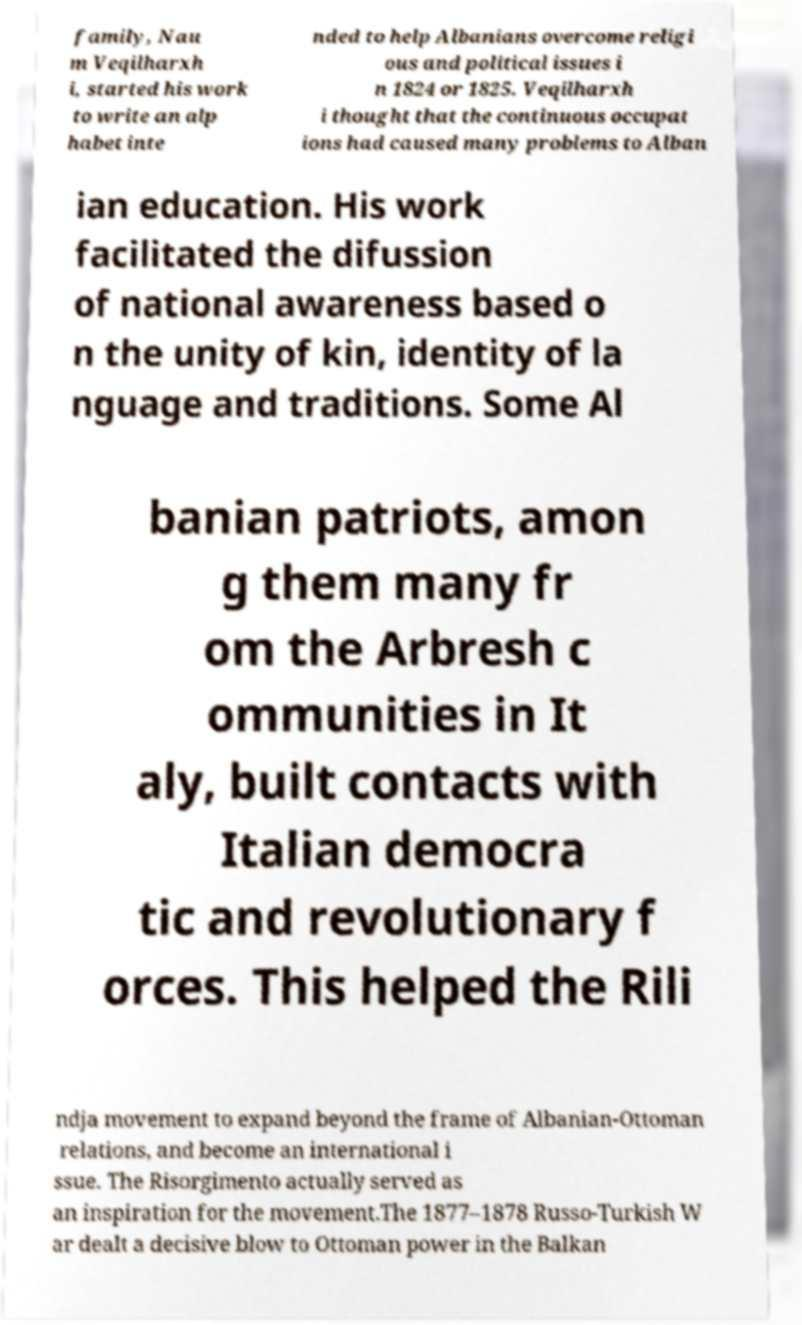Can you accurately transcribe the text from the provided image for me? family, Nau m Veqilharxh i, started his work to write an alp habet inte nded to help Albanians overcome religi ous and political issues i n 1824 or 1825. Veqilharxh i thought that the continuous occupat ions had caused many problems to Alban ian education. His work facilitated the difussion of national awareness based o n the unity of kin, identity of la nguage and traditions. Some Al banian patriots, amon g them many fr om the Arbresh c ommunities in It aly, built contacts with Italian democra tic and revolutionary f orces. This helped the Rili ndja movement to expand beyond the frame of Albanian-Ottoman relations, and become an international i ssue. The Risorgimento actually served as an inspiration for the movement.The 1877–1878 Russo-Turkish W ar dealt a decisive blow to Ottoman power in the Balkan 